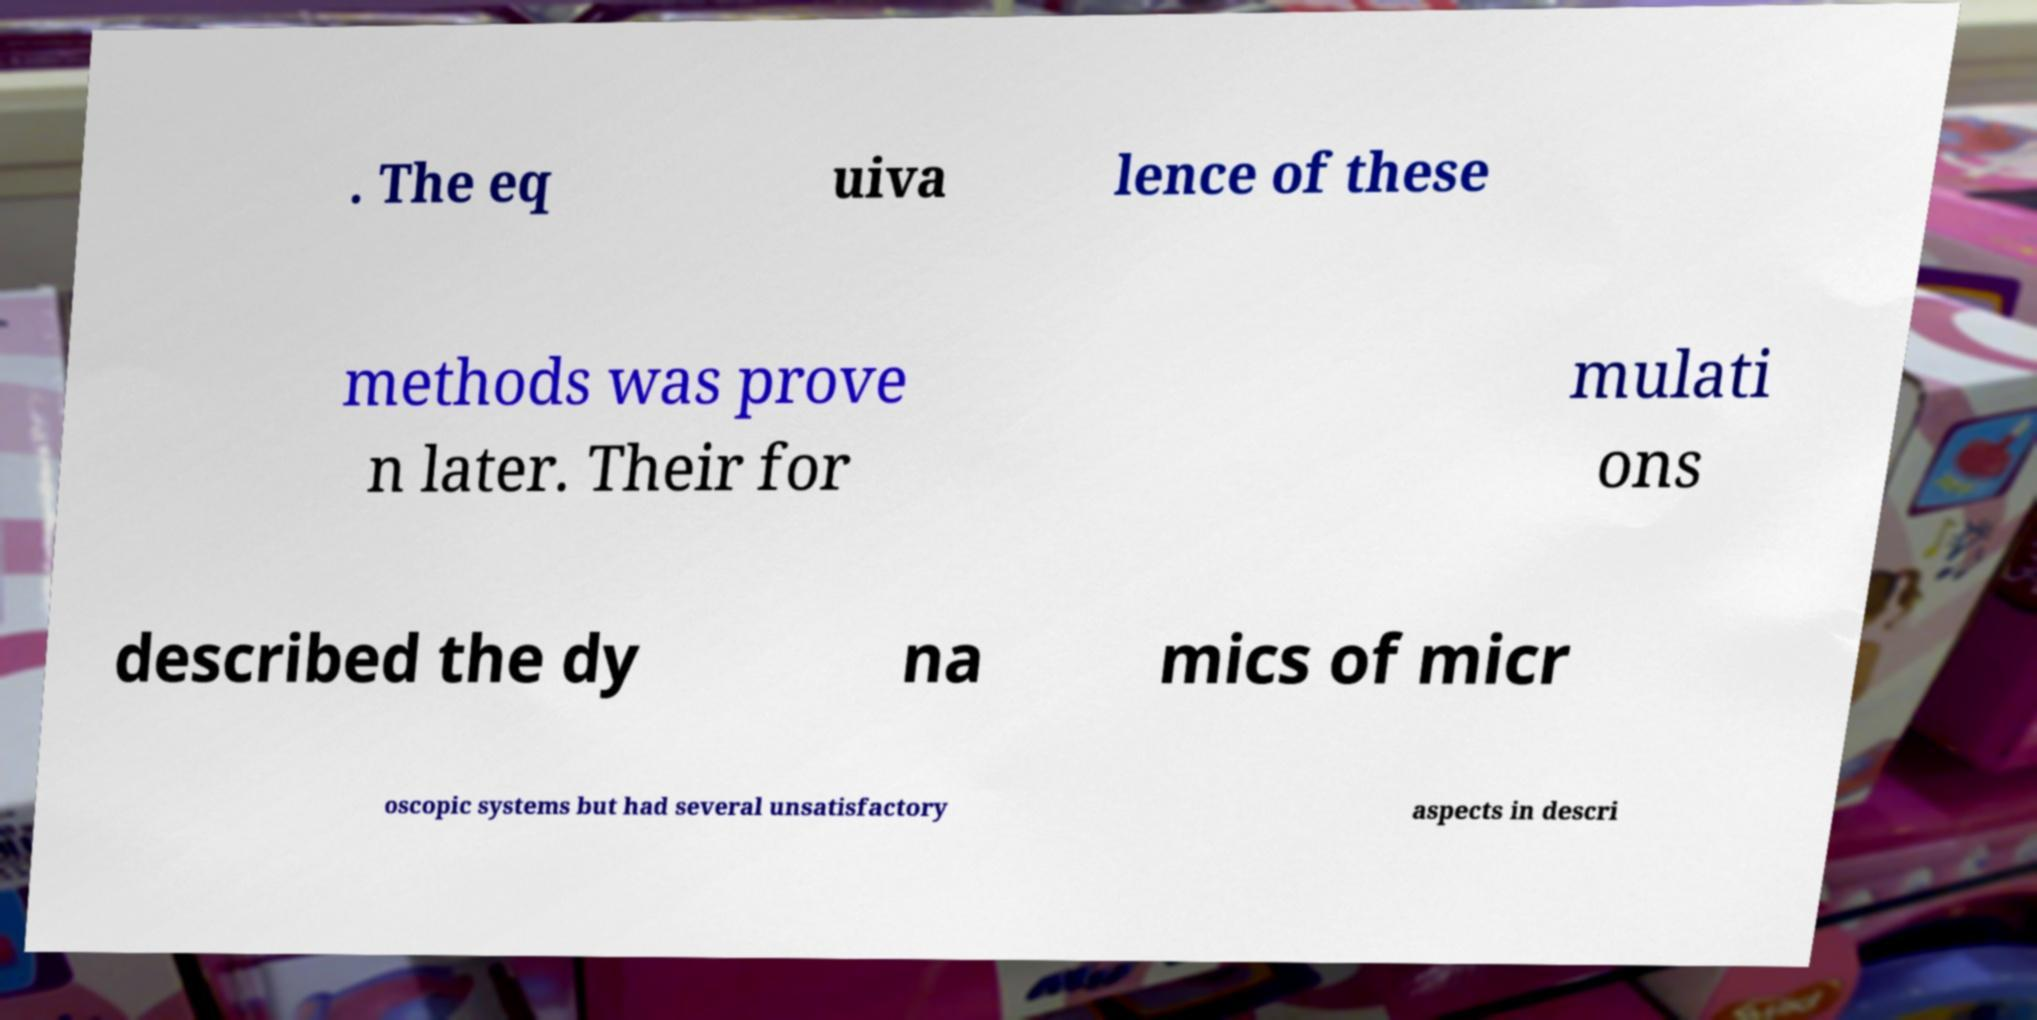Can you accurately transcribe the text from the provided image for me? . The eq uiva lence of these methods was prove n later. Their for mulati ons described the dy na mics of micr oscopic systems but had several unsatisfactory aspects in descri 